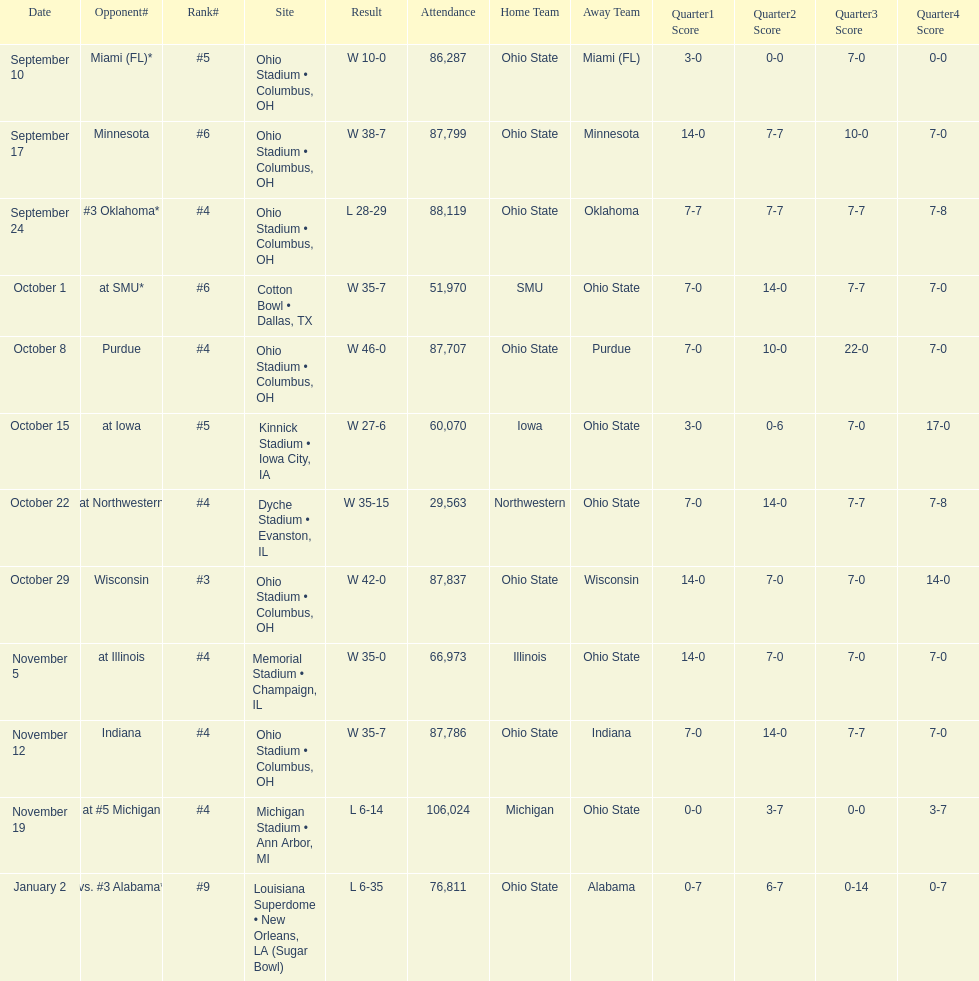Which date was attended by the most people? November 19. Write the full table. {'header': ['Date', 'Opponent#', 'Rank#', 'Site', 'Result', 'Attendance', 'Home Team', 'Away Team', 'Quarter1 Score', 'Quarter2 Score', 'Quarter3 Score', 'Quarter4 Score'], 'rows': [['September 10', 'Miami (FL)*', '#5', 'Ohio Stadium • Columbus, OH', 'W\xa010-0', '86,287', 'Ohio State', 'Miami (FL)', '3-0', '0-0', '7-0', '0-0'], ['September 17', 'Minnesota', '#6', 'Ohio Stadium • Columbus, OH', 'W\xa038-7', '87,799', 'Ohio State', 'Minnesota', '14-0', '7-7', '10-0', '7-0'], ['September 24', '#3\xa0Oklahoma*', '#4', 'Ohio Stadium • Columbus, OH', 'L\xa028-29', '88,119', 'Ohio State', 'Oklahoma', '7-7', '7-7', '7-7', '7-8'], ['October 1', 'at\xa0SMU*', '#6', 'Cotton Bowl • Dallas, TX', 'W\xa035-7', '51,970', 'SMU', 'Ohio State', '7-0', '14-0', '7-7', '7-0'], ['October 8', 'Purdue', '#4', 'Ohio Stadium • Columbus, OH', 'W\xa046-0', '87,707', 'Ohio State', 'Purdue', '7-0', '10-0', '22-0', '7-0'], ['October 15', 'at\xa0Iowa', '#5', 'Kinnick Stadium • Iowa City, IA', 'W\xa027-6', '60,070', 'Iowa', 'Ohio State', '3-0', '0-6', '7-0', '17-0'], ['October 22', 'at\xa0Northwestern', '#4', 'Dyche Stadium • Evanston, IL', 'W\xa035-15', '29,563', 'Northwestern', 'Ohio State', '7-0', '14-0', '7-7', '7-8'], ['October 29', 'Wisconsin', '#3', 'Ohio Stadium • Columbus, OH', 'W\xa042-0', '87,837', 'Ohio State', 'Wisconsin', '14-0', '7-0', '7-0', '14-0'], ['November 5', 'at\xa0Illinois', '#4', 'Memorial Stadium • Champaign, IL', 'W\xa035-0', '66,973', 'Illinois', 'Ohio State', '14-0', '7-0', '7-0', '7-0'], ['November 12', 'Indiana', '#4', 'Ohio Stadium • Columbus, OH', 'W\xa035-7', '87,786', 'Ohio State', 'Indiana', '7-0', '14-0', '7-7', '7-0'], ['November 19', 'at\xa0#5\xa0Michigan', '#4', 'Michigan Stadium • Ann Arbor, MI', 'L\xa06-14', '106,024', 'Michigan', 'Ohio State', '0-0', '3-7', '0-0', '3-7'], ['January 2', 'vs.\xa0#3\xa0Alabama*', '#9', 'Louisiana Superdome • New Orleans, LA (Sugar Bowl)', 'L\xa06-35', '76,811', 'Ohio State', 'Alabama', '0-7', '6-7', '0-14', '0-7']]} 